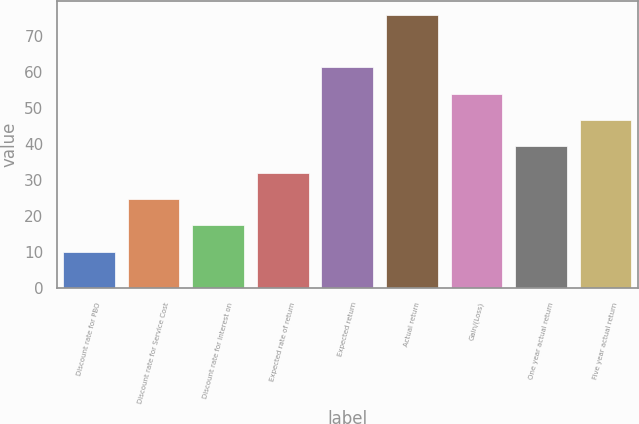Convert chart to OTSL. <chart><loc_0><loc_0><loc_500><loc_500><bar_chart><fcel>Discount rate for PBO<fcel>Discount rate for Service Cost<fcel>Discount rate for Interest on<fcel>Expected rate of return<fcel>Expected return<fcel>Actual return<fcel>Gain/(Loss)<fcel>One year actual return<fcel>Five year actual return<nl><fcel>10.21<fcel>24.83<fcel>17.52<fcel>32.14<fcel>61.38<fcel>76<fcel>54.07<fcel>39.45<fcel>46.76<nl></chart> 